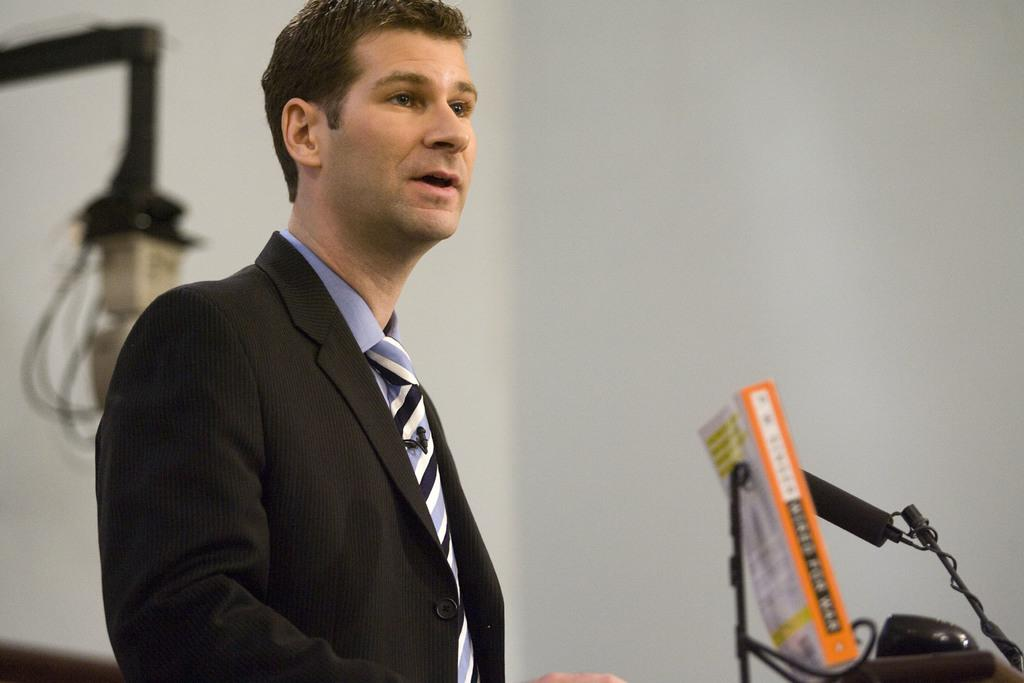What is the man in the image wearing? The man is wearing a suit, a shirt, and a tie. What object can be seen near the man in the image? There is a book, a microphone with a stand, and a lamp in the image. What type of background is visible in the image? There is a wall in the image. What type of cherry is the man holding in the image? There is no cherry present in the image. What theory does the man propose in the image? The image does not provide any information about a theory proposed by the man. 